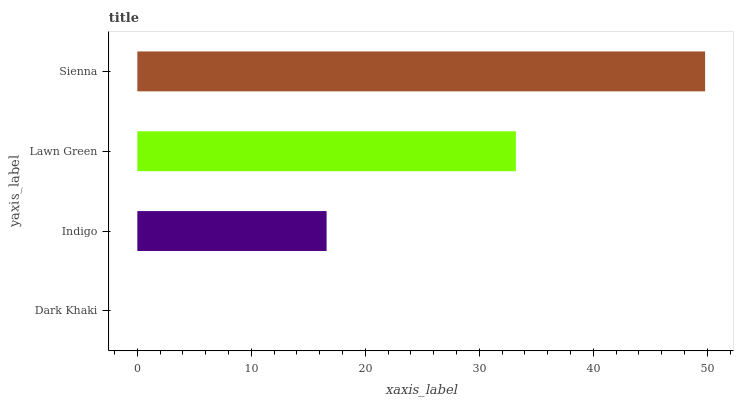Is Dark Khaki the minimum?
Answer yes or no. Yes. Is Sienna the maximum?
Answer yes or no. Yes. Is Indigo the minimum?
Answer yes or no. No. Is Indigo the maximum?
Answer yes or no. No. Is Indigo greater than Dark Khaki?
Answer yes or no. Yes. Is Dark Khaki less than Indigo?
Answer yes or no. Yes. Is Dark Khaki greater than Indigo?
Answer yes or no. No. Is Indigo less than Dark Khaki?
Answer yes or no. No. Is Lawn Green the high median?
Answer yes or no. Yes. Is Indigo the low median?
Answer yes or no. Yes. Is Dark Khaki the high median?
Answer yes or no. No. Is Dark Khaki the low median?
Answer yes or no. No. 